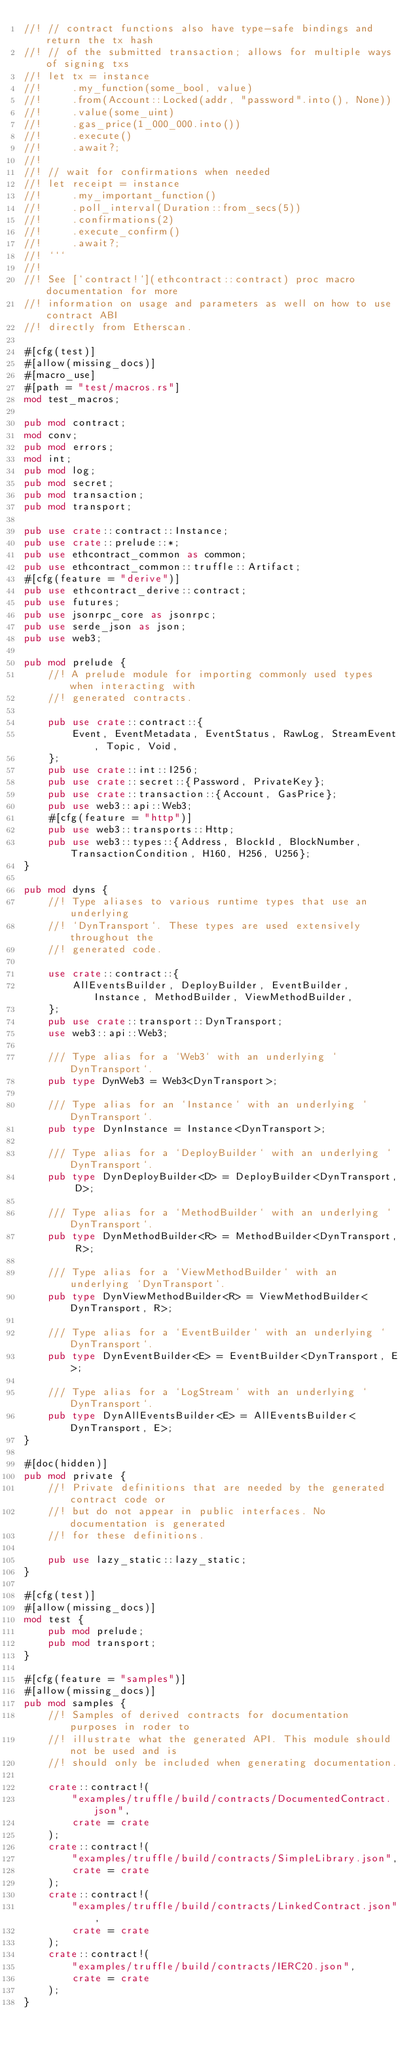Convert code to text. <code><loc_0><loc_0><loc_500><loc_500><_Rust_>//! // contract functions also have type-safe bindings and return the tx hash
//! // of the submitted transaction; allows for multiple ways of signing txs
//! let tx = instance
//!     .my_function(some_bool, value)
//!     .from(Account::Locked(addr, "password".into(), None))
//!     .value(some_uint)
//!     .gas_price(1_000_000.into())
//!     .execute()
//!     .await?;
//!
//! // wait for confirmations when needed
//! let receipt = instance
//!     .my_important_function()
//!     .poll_interval(Duration::from_secs(5))
//!     .confirmations(2)
//!     .execute_confirm()
//!     .await?;
//! ```
//!
//! See [`contract!`](ethcontract::contract) proc macro documentation for more
//! information on usage and parameters as well on how to use contract ABI
//! directly from Etherscan.

#[cfg(test)]
#[allow(missing_docs)]
#[macro_use]
#[path = "test/macros.rs"]
mod test_macros;

pub mod contract;
mod conv;
pub mod errors;
mod int;
pub mod log;
pub mod secret;
pub mod transaction;
pub mod transport;

pub use crate::contract::Instance;
pub use crate::prelude::*;
pub use ethcontract_common as common;
pub use ethcontract_common::truffle::Artifact;
#[cfg(feature = "derive")]
pub use ethcontract_derive::contract;
pub use futures;
pub use jsonrpc_core as jsonrpc;
pub use serde_json as json;
pub use web3;

pub mod prelude {
    //! A prelude module for importing commonly used types when interacting with
    //! generated contracts.

    pub use crate::contract::{
        Event, EventMetadata, EventStatus, RawLog, StreamEvent, Topic, Void,
    };
    pub use crate::int::I256;
    pub use crate::secret::{Password, PrivateKey};
    pub use crate::transaction::{Account, GasPrice};
    pub use web3::api::Web3;
    #[cfg(feature = "http")]
    pub use web3::transports::Http;
    pub use web3::types::{Address, BlockId, BlockNumber, TransactionCondition, H160, H256, U256};
}

pub mod dyns {
    //! Type aliases to various runtime types that use an underlying
    //! `DynTransport`. These types are used extensively throughout the
    //! generated code.

    use crate::contract::{
        AllEventsBuilder, DeployBuilder, EventBuilder, Instance, MethodBuilder, ViewMethodBuilder,
    };
    pub use crate::transport::DynTransport;
    use web3::api::Web3;

    /// Type alias for a `Web3` with an underlying `DynTransport`.
    pub type DynWeb3 = Web3<DynTransport>;

    /// Type alias for an `Instance` with an underlying `DynTransport`.
    pub type DynInstance = Instance<DynTransport>;

    /// Type alias for a `DeployBuilder` with an underlying `DynTransport`.
    pub type DynDeployBuilder<D> = DeployBuilder<DynTransport, D>;

    /// Type alias for a `MethodBuilder` with an underlying `DynTransport`.
    pub type DynMethodBuilder<R> = MethodBuilder<DynTransport, R>;

    /// Type alias for a `ViewMethodBuilder` with an underlying `DynTransport`.
    pub type DynViewMethodBuilder<R> = ViewMethodBuilder<DynTransport, R>;

    /// Type alias for a `EventBuilder` with an underlying `DynTransport`.
    pub type DynEventBuilder<E> = EventBuilder<DynTransport, E>;

    /// Type alias for a `LogStream` with an underlying `DynTransport`.
    pub type DynAllEventsBuilder<E> = AllEventsBuilder<DynTransport, E>;
}

#[doc(hidden)]
pub mod private {
    //! Private definitions that are needed by the generated contract code or
    //! but do not appear in public interfaces. No documentation is generated
    //! for these definitions.

    pub use lazy_static::lazy_static;
}

#[cfg(test)]
#[allow(missing_docs)]
mod test {
    pub mod prelude;
    pub mod transport;
}

#[cfg(feature = "samples")]
#[allow(missing_docs)]
pub mod samples {
    //! Samples of derived contracts for documentation purposes in roder to
    //! illustrate what the generated API. This module should not be used and is
    //! should only be included when generating documentation.

    crate::contract!(
        "examples/truffle/build/contracts/DocumentedContract.json",
        crate = crate
    );
    crate::contract!(
        "examples/truffle/build/contracts/SimpleLibrary.json",
        crate = crate
    );
    crate::contract!(
        "examples/truffle/build/contracts/LinkedContract.json",
        crate = crate
    );
    crate::contract!(
        "examples/truffle/build/contracts/IERC20.json",
        crate = crate
    );
}
</code> 